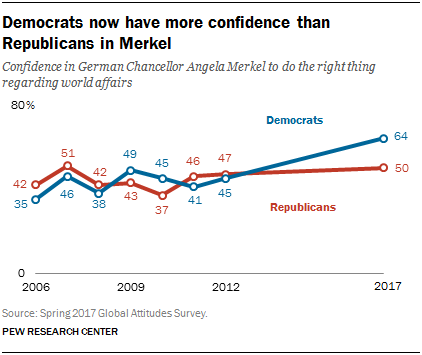Specify some key components in this picture. The blue line represents the Democratic Party. The tallest thread is blue in color. 